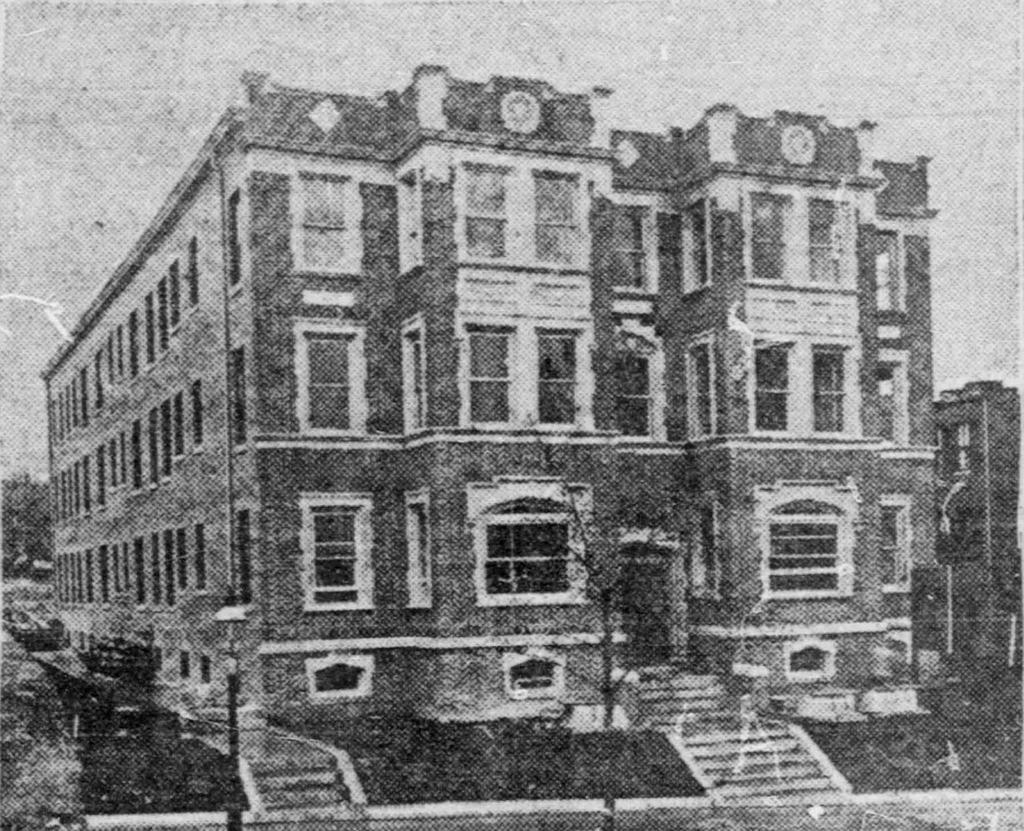What type of picture is present in the image? There is a black and white picture in the image. What is depicted in the black and white picture? The black and white picture contains a building. What type of cent can be seen in the image? There is no cent present in the image. What type of stew is being prepared in the image? There is no stew or cooking activity present in the image. 